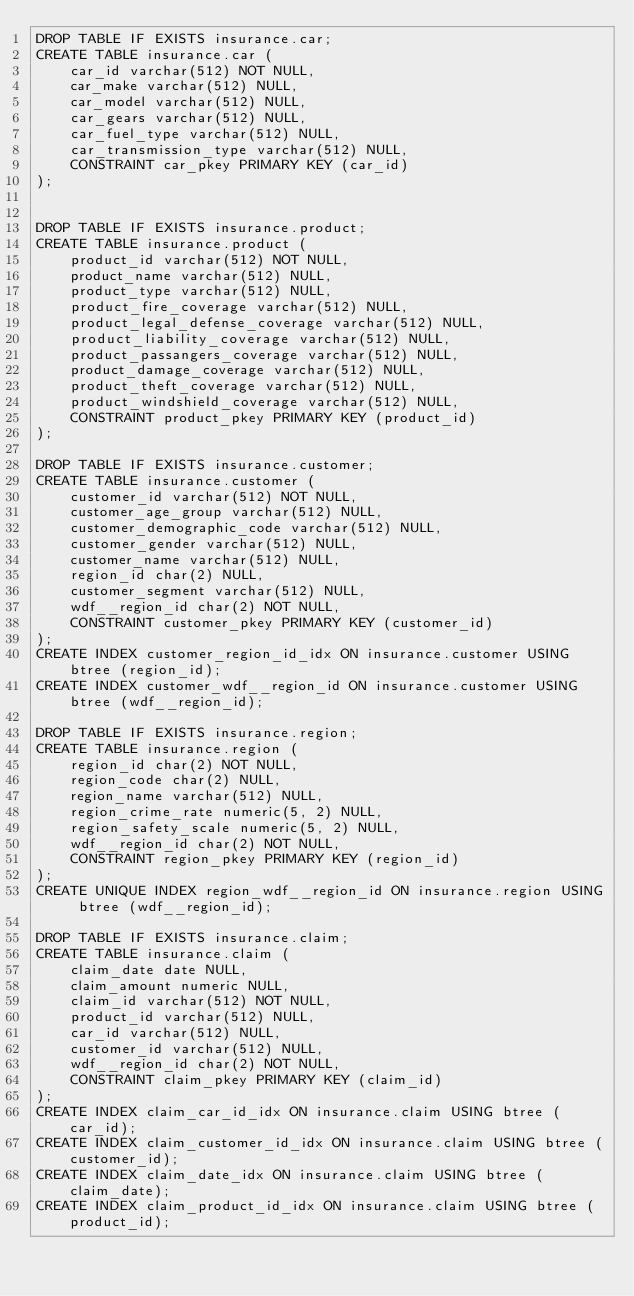Convert code to text. <code><loc_0><loc_0><loc_500><loc_500><_SQL_>DROP TABLE IF EXISTS insurance.car;
CREATE TABLE insurance.car (
	car_id varchar(512) NOT NULL,
	car_make varchar(512) NULL,
	car_model varchar(512) NULL,
	car_gears varchar(512) NULL,
	car_fuel_type varchar(512) NULL,
	car_transmission_type varchar(512) NULL,
	CONSTRAINT car_pkey PRIMARY KEY (car_id)
);


DROP TABLE IF EXISTS insurance.product;
CREATE TABLE insurance.product (
	product_id varchar(512) NOT NULL,
	product_name varchar(512) NULL,
	product_type varchar(512) NULL,
	product_fire_coverage varchar(512) NULL,
	product_legal_defense_coverage varchar(512) NULL,
	product_liability_coverage varchar(512) NULL,
	product_passangers_coverage varchar(512) NULL,
	product_damage_coverage varchar(512) NULL,
	product_theft_coverage varchar(512) NULL,
	product_windshield_coverage varchar(512) NULL,
	CONSTRAINT product_pkey PRIMARY KEY (product_id)
);

DROP TABLE IF EXISTS insurance.customer;
CREATE TABLE insurance.customer (
	customer_id varchar(512) NOT NULL,
	customer_age_group varchar(512) NULL,
	customer_demographic_code varchar(512) NULL,
	customer_gender varchar(512) NULL,
	customer_name varchar(512) NULL,
	region_id char(2) NULL,
	customer_segment varchar(512) NULL,
	wdf__region_id char(2) NOT NULL,
	CONSTRAINT customer_pkey PRIMARY KEY (customer_id)
);
CREATE INDEX customer_region_id_idx ON insurance.customer USING btree (region_id);
CREATE INDEX customer_wdf__region_id ON insurance.customer USING btree (wdf__region_id);

DROP TABLE IF EXISTS insurance.region;
CREATE TABLE insurance.region (
	region_id char(2) NOT NULL,
	region_code char(2) NULL,
	region_name varchar(512) NULL,
	region_crime_rate numeric(5, 2) NULL,
	region_safety_scale numeric(5, 2) NULL,
	wdf__region_id char(2) NOT NULL,
	CONSTRAINT region_pkey PRIMARY KEY (region_id)
);
CREATE UNIQUE INDEX region_wdf__region_id ON insurance.region USING btree (wdf__region_id);

DROP TABLE IF EXISTS insurance.claim;
CREATE TABLE insurance.claim (
	claim_date date NULL,
	claim_amount numeric NULL,
	claim_id varchar(512) NOT NULL,
	product_id varchar(512) NULL,
	car_id varchar(512) NULL,
	customer_id varchar(512) NULL,
	wdf__region_id char(2) NOT NULL,
	CONSTRAINT claim_pkey PRIMARY KEY (claim_id)
);
CREATE INDEX claim_car_id_idx ON insurance.claim USING btree (car_id);
CREATE INDEX claim_customer_id_idx ON insurance.claim USING btree (customer_id);
CREATE INDEX claim_date_idx ON insurance.claim USING btree (claim_date);
CREATE INDEX claim_product_id_idx ON insurance.claim USING btree (product_id);</code> 